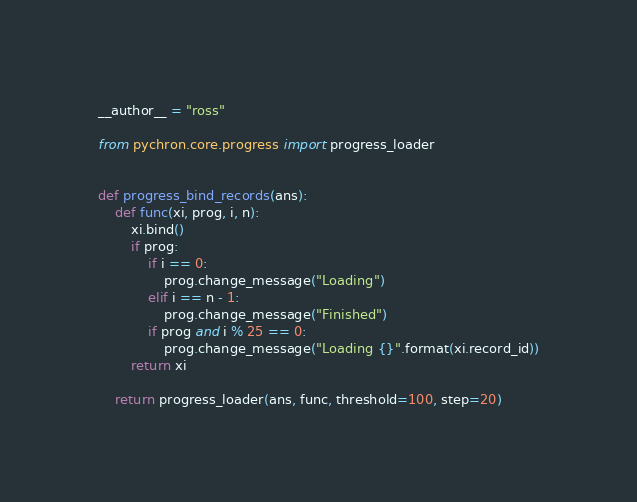Convert code to text. <code><loc_0><loc_0><loc_500><loc_500><_Python_>__author__ = "ross"

from pychron.core.progress import progress_loader


def progress_bind_records(ans):
    def func(xi, prog, i, n):
        xi.bind()
        if prog:
            if i == 0:
                prog.change_message("Loading")
            elif i == n - 1:
                prog.change_message("Finished")
            if prog and i % 25 == 0:
                prog.change_message("Loading {}".format(xi.record_id))
        return xi

    return progress_loader(ans, func, threshold=100, step=20)
</code> 